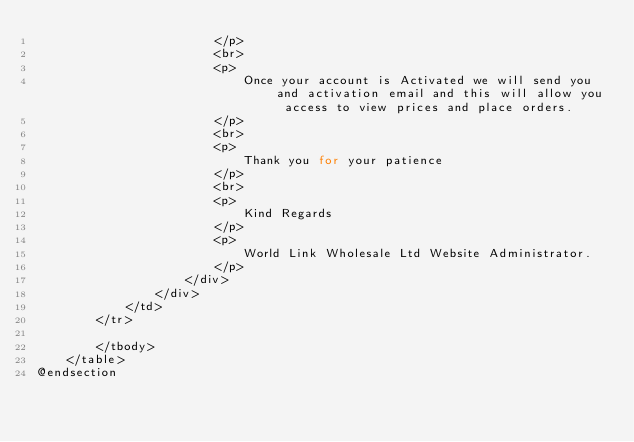<code> <loc_0><loc_0><loc_500><loc_500><_PHP_>                        </p>
                        <br>
                        <p>
                            Once your account is Activated we will send you and activation email and this will allow you access to view prices and place orders.
                        </p>
                        <br>
                        <p>
                            Thank you for your patience
                        </p>
                        <br>
                        <p>
                            Kind Regards
                        </p>
                        <p>
                            World Link Wholesale Ltd Website Administrator.
                        </p>
                    </div>
                </div>
            </td>
        </tr>

        </tbody>
    </table>
@endsection
</code> 